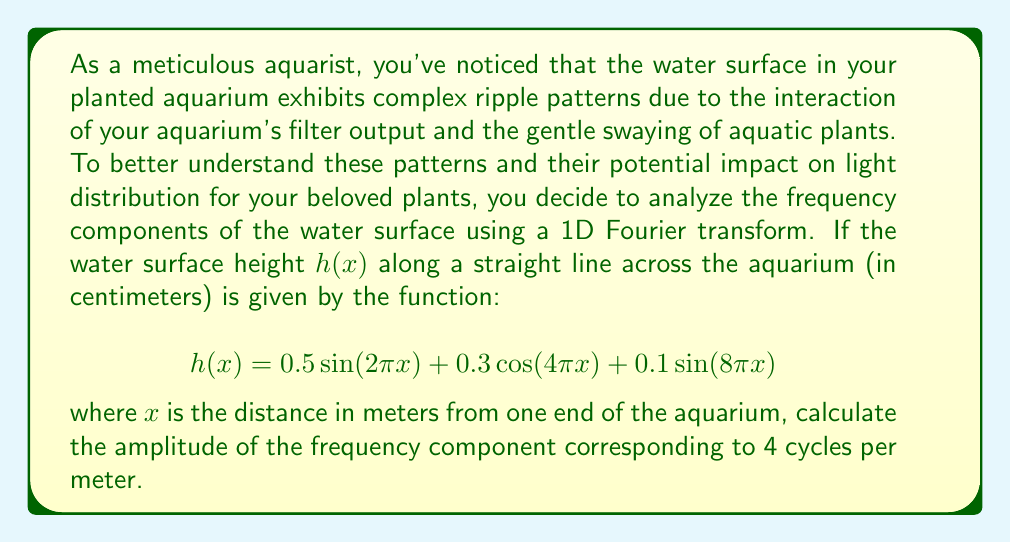Can you solve this math problem? To solve this problem, we need to analyze the given function $h(x)$ and identify the term that corresponds to 4 cycles per meter. Let's break it down step by step:

1) The general form of a sinusoidal function is $A \sin(2\pi fx)$ or $A \cos(2\pi fx)$, where:
   - $A$ is the amplitude
   - $f$ is the frequency (cycles per meter)
   - $x$ is the distance (in meters)

2) Let's examine each term in the given function:

   a) $0.5 \sin(2\pi x)$:
      Frequency = 1 cycle/meter, Amplitude = 0.5 cm

   b) $0.3 \cos(4\pi x)$:
      Frequency = 2 cycles/meter, Amplitude = 0.3 cm

   c) $0.1 \sin(8\pi x)$:
      Frequency = 4 cycles/meter, Amplitude = 0.1 cm

3) The question asks for the amplitude of the frequency component corresponding to 4 cycles per meter.

4) From our analysis, we can see that the term $0.1 \sin(8\pi x)$ represents 4 cycles per meter.

5) Therefore, the amplitude of the frequency component corresponding to 4 cycles per meter is 0.1 cm.

This analysis helps us understand the contribution of different frequency components to the overall water surface pattern, which can affect light refraction and distribution in the aquarium, potentially impacting plant growth and health.
Answer: 0.1 cm 